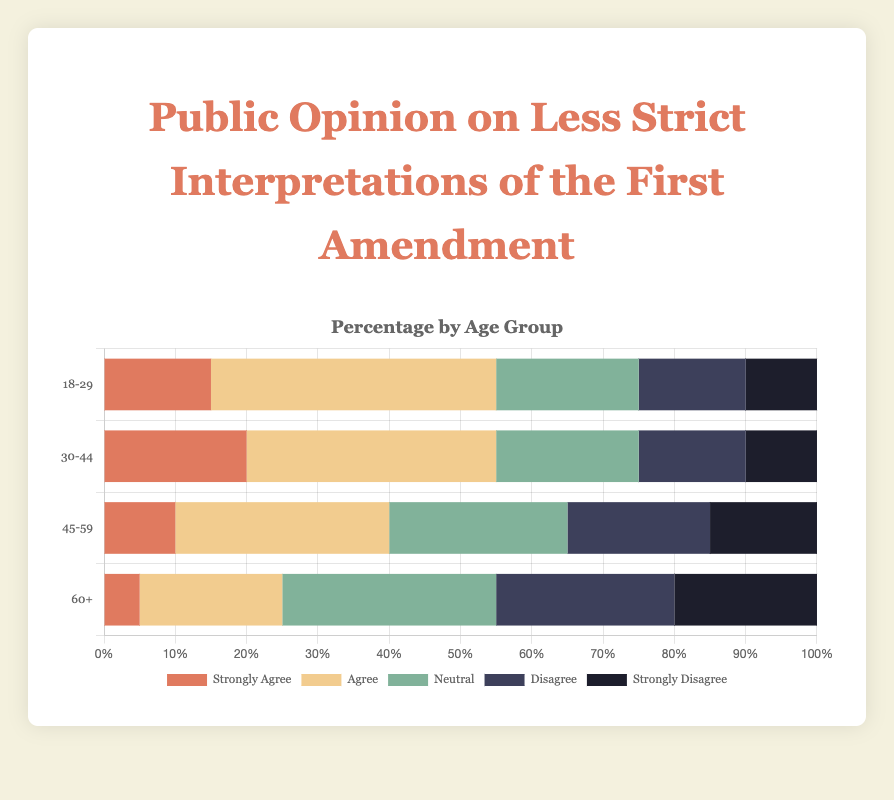Which age group shows the highest percentage of agreement (agree + strongly agree) with less strict interpretations of the First Amendment? The age group 18-29 has 40% agreeing and 15% strongly agreeing, totaling 55%.
Answer: 18-29 What is the total percentage of the 'neutral' response across all age groups? Summing up the 'neutral' percentages from all age groups: 20% + 20% + 25% + 30% = 95%.
Answer: 95% Which age group has the largest proportion of strong disagreement? Age group 60+ has the highest ‘strongly disagree’ percentage at 20%.
Answer: 60+ Compare the total percentage of disagreement (disagree + strongly disagree) between the 45-59 and 60+ age groups. Which one is higher? For ages 45-59, the total disagreement is 20% + 15% = 35%. For ages 60+, it is 25% + 20% = 45%. Thus, the 60+ group has a higher total percentage of disagreement.
Answer: 60+ What is the net agreement (agree - disagree) for the age group 30-44? The 30-44 age group has 35% agree and 15% disagree, resulting in a net agreement of 35% - 15% = 20%.
Answer: 20% Among the given age groups, which one has the smallest proportion of 'neutral' responses? The age groups 18-29 and 30-44 both have the smallest 'neutral' percentage at 20%.
Answer: 18-29 and 30-44 What is the difference in the percentage of 'strongly disagree' between the youngest (18-29) and the oldest (60+) age groups? The 'strongly disagree' percentage for 18-29 is 10% and for 60+ it is 20%, so the difference is 20% - 10% = 10%.
Answer: 10% Which two age groups have the most similar distribution in their response (including all categories)? The age groups 18-29 and 30-44 have the most similar distributions with agree, disagree, and neutral responses being close in percentage.
Answer: 18-29 and 30-44 How does the percentage of people who 'disagree' change from the youngest to the oldest age group? The 'disagree' percentage increases with age: 18-29 (15%), 30-44 (15%), 45-59 (20%), 60+ (25%).
Answer: Increases 